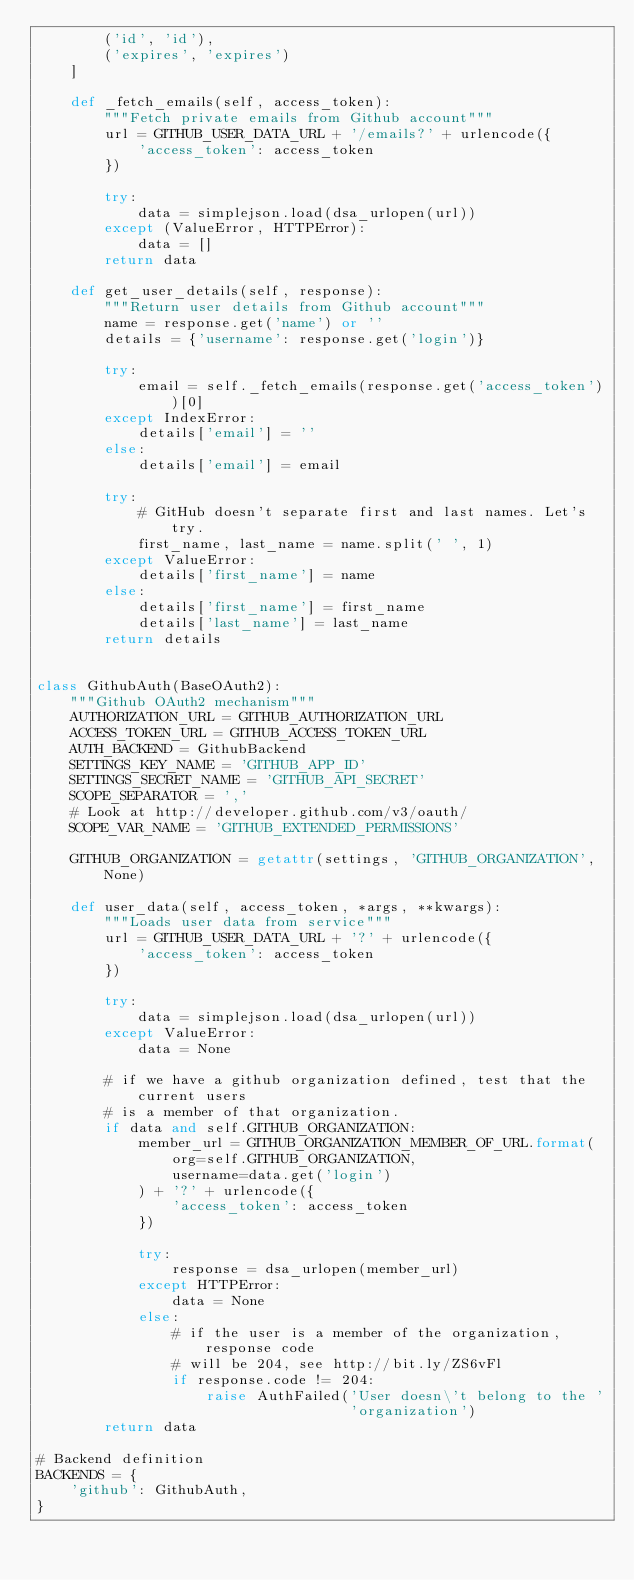<code> <loc_0><loc_0><loc_500><loc_500><_Python_>        ('id', 'id'),
        ('expires', 'expires')
    ]

    def _fetch_emails(self, access_token):
        """Fetch private emails from Github account"""
        url = GITHUB_USER_DATA_URL + '/emails?' + urlencode({
            'access_token': access_token
        })

        try:
            data = simplejson.load(dsa_urlopen(url))
        except (ValueError, HTTPError):
            data = []
        return data

    def get_user_details(self, response):
        """Return user details from Github account"""
        name = response.get('name') or ''
        details = {'username': response.get('login')}

        try:
            email = self._fetch_emails(response.get('access_token'))[0]
        except IndexError:
            details['email'] = ''
        else:
            details['email'] = email

        try:
            # GitHub doesn't separate first and last names. Let's try.
            first_name, last_name = name.split(' ', 1)
        except ValueError:
            details['first_name'] = name
        else:
            details['first_name'] = first_name
            details['last_name'] = last_name
        return details


class GithubAuth(BaseOAuth2):
    """Github OAuth2 mechanism"""
    AUTHORIZATION_URL = GITHUB_AUTHORIZATION_URL
    ACCESS_TOKEN_URL = GITHUB_ACCESS_TOKEN_URL
    AUTH_BACKEND = GithubBackend
    SETTINGS_KEY_NAME = 'GITHUB_APP_ID'
    SETTINGS_SECRET_NAME = 'GITHUB_API_SECRET'
    SCOPE_SEPARATOR = ','
    # Look at http://developer.github.com/v3/oauth/
    SCOPE_VAR_NAME = 'GITHUB_EXTENDED_PERMISSIONS'

    GITHUB_ORGANIZATION = getattr(settings, 'GITHUB_ORGANIZATION', None)

    def user_data(self, access_token, *args, **kwargs):
        """Loads user data from service"""
        url = GITHUB_USER_DATA_URL + '?' + urlencode({
            'access_token': access_token
        })

        try:
            data = simplejson.load(dsa_urlopen(url))
        except ValueError:
            data = None

        # if we have a github organization defined, test that the current users
        # is a member of that organization.
        if data and self.GITHUB_ORGANIZATION:
            member_url = GITHUB_ORGANIZATION_MEMBER_OF_URL.format(
                org=self.GITHUB_ORGANIZATION,
                username=data.get('login')
            ) + '?' + urlencode({
                'access_token': access_token
            })

            try:
                response = dsa_urlopen(member_url)
            except HTTPError:
                data = None
            else:
                # if the user is a member of the organization, response code
                # will be 204, see http://bit.ly/ZS6vFl
                if response.code != 204:
                    raise AuthFailed('User doesn\'t belong to the '
                                     'organization')
        return data

# Backend definition
BACKENDS = {
    'github': GithubAuth,
}
</code> 